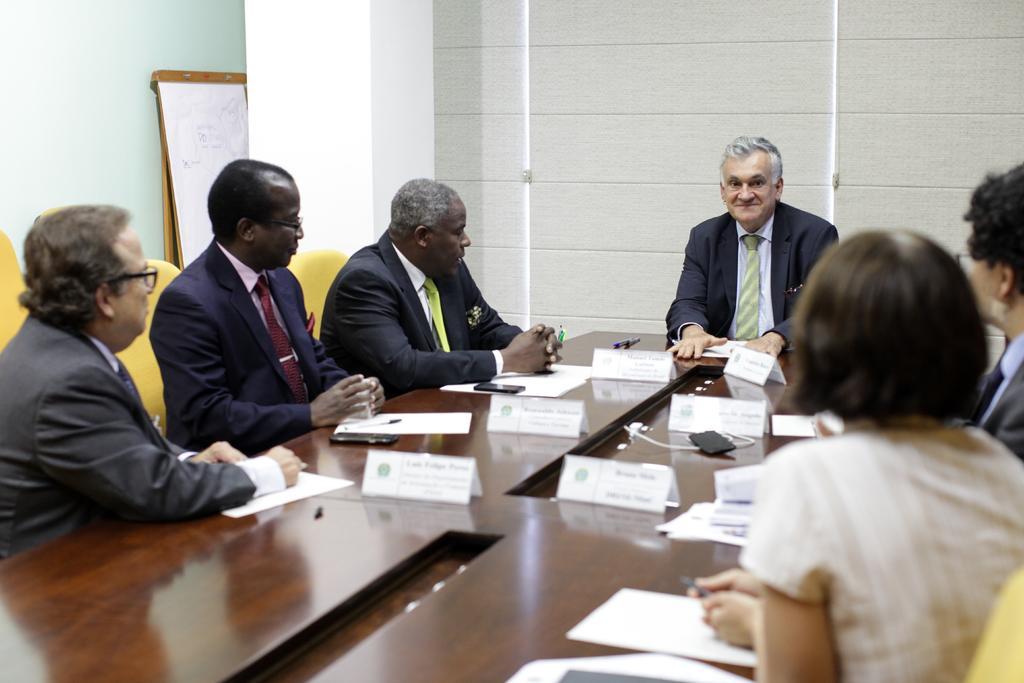Can you describe this image briefly? In this picture I can see there are a few people sitting in the chairs, they have a table in front of them with papers, name boards, pens and there is a pillar at the left side backdrop, there is window and it is covered with a curtain. 